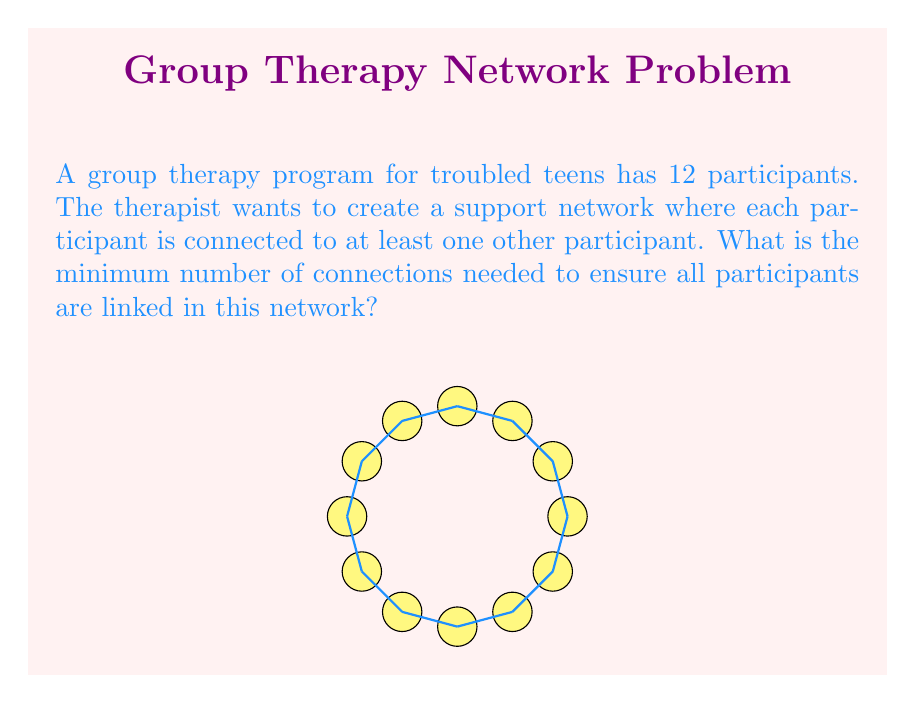Provide a solution to this math problem. To solve this problem, we can use concepts from graph theory:

1) Each participant can be represented as a vertex in a graph.

2) The connections between participants are edges in the graph.

3) We need to find the minimum number of edges that connect all vertices, which is essentially asking for a minimum spanning tree of the graph.

4) In graph theory, a tree is a connected graph with no cycles.

5) A tree with $n$ vertices always has exactly $n-1$ edges.

6) In this case, we have 12 participants (vertices), so the minimum number of connections (edges) needed is:

   $$ n - 1 = 12 - 1 = 11 $$

This configuration ensures that all participants are connected with the minimum number of links, forming a tree-like structure in the support network.
Answer: 11 connections 